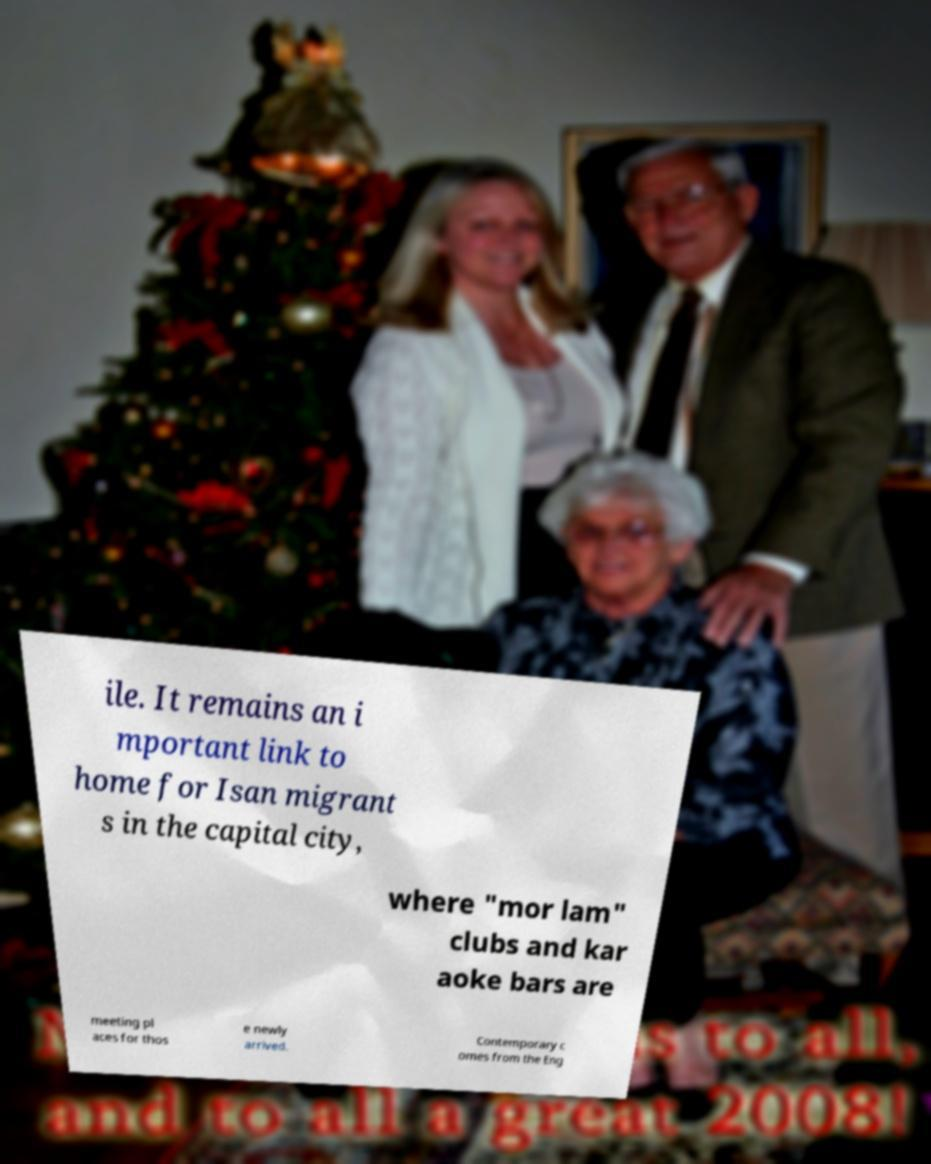Please identify and transcribe the text found in this image. ile. It remains an i mportant link to home for Isan migrant s in the capital city, where "mor lam" clubs and kar aoke bars are meeting pl aces for thos e newly arrived. Contemporary c omes from the Eng 